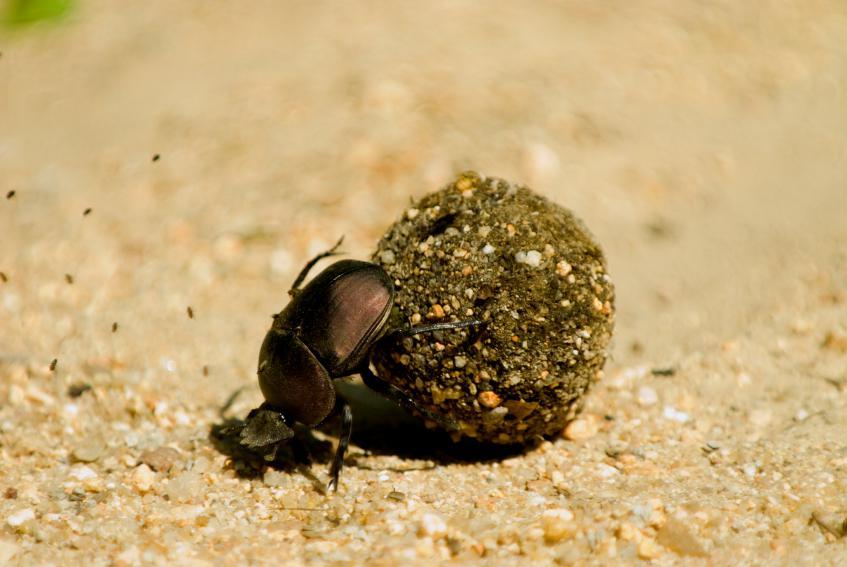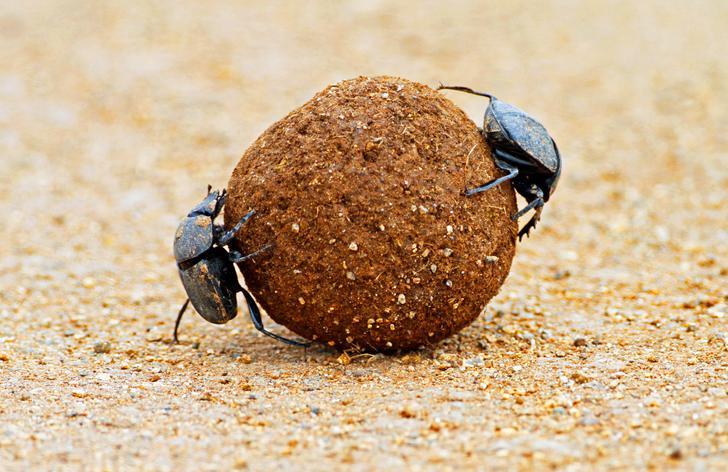The first image is the image on the left, the second image is the image on the right. For the images displayed, is the sentence "There are two beetles near one clod of dirt in one of the images." factually correct? Answer yes or no. Yes. The first image is the image on the left, the second image is the image on the right. Analyze the images presented: Is the assertion "Each image includes a beetle with a dungball that is bigger than the beetle." valid? Answer yes or no. Yes. 